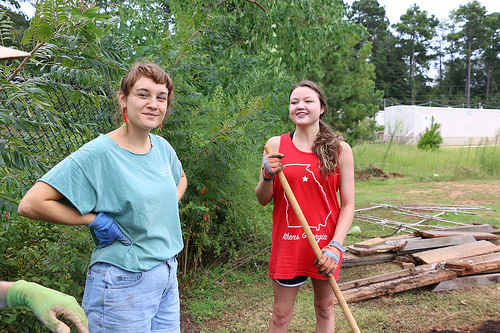<image>
Can you confirm if the woman is to the left of the woman? Yes. From this viewpoint, the woman is positioned to the left side relative to the woman. 